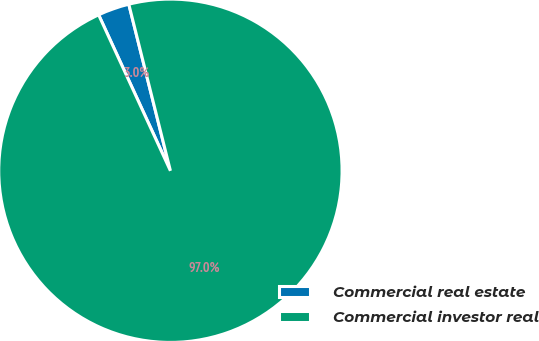Convert chart to OTSL. <chart><loc_0><loc_0><loc_500><loc_500><pie_chart><fcel>Commercial real estate<fcel>Commercial investor real<nl><fcel>2.97%<fcel>97.03%<nl></chart> 